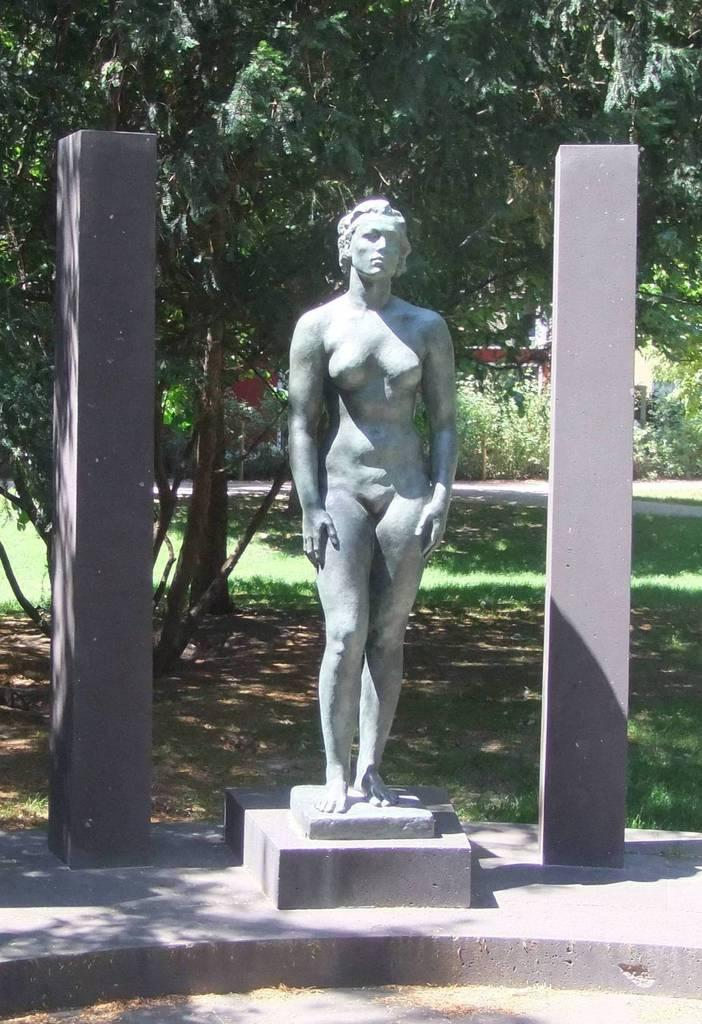What is the main subject in the foreground of the image? There is a sculpture in the foreground of the image. What structures are located beside the sculpture? There are two pillars beside the sculpture. What can be seen in the background of the image? There are trees, grass, and a path in the background of the image. What type of celery is growing beside the path in the image? There is no celery present in the image; the background features trees and grass, but no celery. Is there a house visible in the image? No, there is no house visible in the image; the main subjects are the sculpture, pillars, and the elements in the background. 